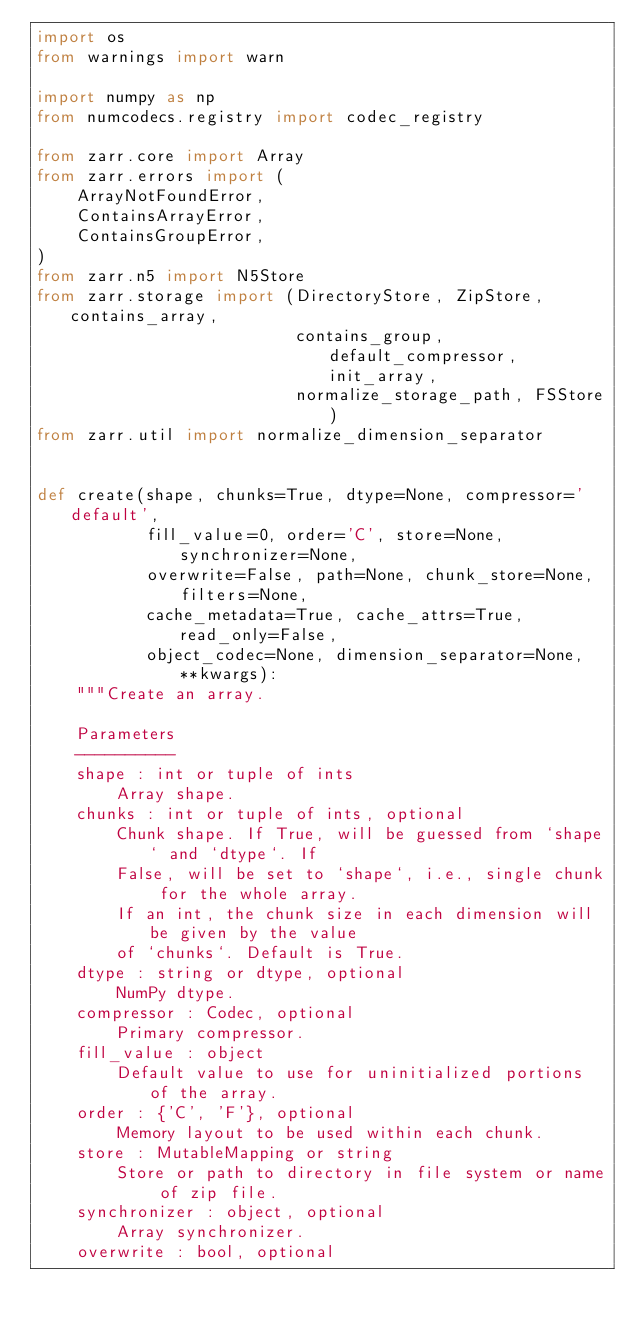<code> <loc_0><loc_0><loc_500><loc_500><_Python_>import os
from warnings import warn

import numpy as np
from numcodecs.registry import codec_registry

from zarr.core import Array
from zarr.errors import (
    ArrayNotFoundError,
    ContainsArrayError,
    ContainsGroupError,
)
from zarr.n5 import N5Store
from zarr.storage import (DirectoryStore, ZipStore, contains_array,
                          contains_group, default_compressor, init_array,
                          normalize_storage_path, FSStore)
from zarr.util import normalize_dimension_separator


def create(shape, chunks=True, dtype=None, compressor='default',
           fill_value=0, order='C', store=None, synchronizer=None,
           overwrite=False, path=None, chunk_store=None, filters=None,
           cache_metadata=True, cache_attrs=True, read_only=False,
           object_codec=None, dimension_separator=None, **kwargs):
    """Create an array.

    Parameters
    ----------
    shape : int or tuple of ints
        Array shape.
    chunks : int or tuple of ints, optional
        Chunk shape. If True, will be guessed from `shape` and `dtype`. If
        False, will be set to `shape`, i.e., single chunk for the whole array.
        If an int, the chunk size in each dimension will be given by the value
        of `chunks`. Default is True.
    dtype : string or dtype, optional
        NumPy dtype.
    compressor : Codec, optional
        Primary compressor.
    fill_value : object
        Default value to use for uninitialized portions of the array.
    order : {'C', 'F'}, optional
        Memory layout to be used within each chunk.
    store : MutableMapping or string
        Store or path to directory in file system or name of zip file.
    synchronizer : object, optional
        Array synchronizer.
    overwrite : bool, optional</code> 